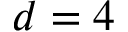Convert formula to latex. <formula><loc_0><loc_0><loc_500><loc_500>d = 4</formula> 